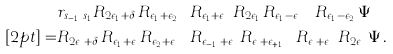<formula> <loc_0><loc_0><loc_500><loc_500>& r _ { s _ { i - 1 } \cdots \, s _ { 1 } } R _ { 2 \epsilon _ { 1 } + \delta } \, R _ { \epsilon _ { 1 } + \epsilon _ { 2 } } \cdots \, R _ { \epsilon _ { 1 } + \epsilon _ { n } } \, R _ { 2 \epsilon _ { 1 } } \, R _ { \epsilon _ { 1 } - \epsilon _ { n } } \cdots \, R _ { \epsilon _ { 1 } - \epsilon _ { 2 } } \, \Psi \\ [ 2 p t ] = & R _ { 2 \epsilon _ { i } + \delta } \, R _ { \epsilon _ { 1 } + \epsilon _ { i } } R _ { \epsilon _ { 2 } + \epsilon _ { i } } \cdots \, R _ { \epsilon _ { i - 1 } + \epsilon _ { i } } \, R _ { \epsilon _ { i } + \epsilon _ { i + 1 } } \cdots R _ { \epsilon _ { i } + \epsilon _ { n } } \, R _ { 2 \epsilon _ { i } } \, \Psi \, .</formula> 